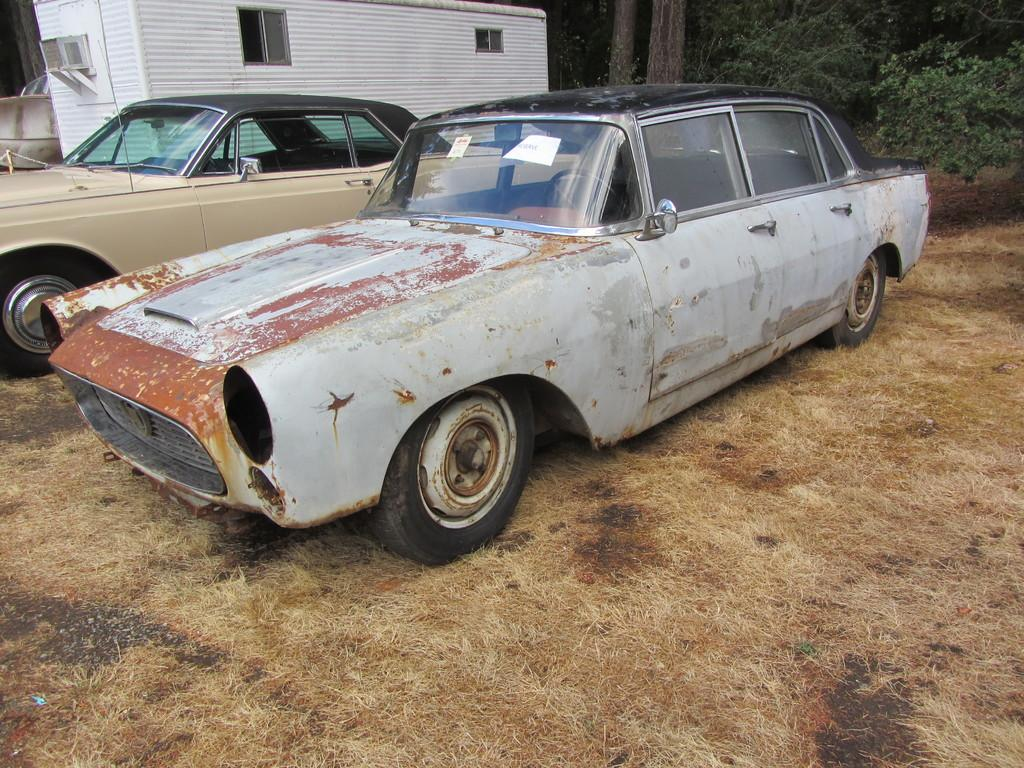How many cars are present in the image? There are two cars in the image. What is the surface on which the cars are located? The cars are on dry grass. What can be seen in the background of the image? There is a house and plants in the background of the image. What type of teaching is being conducted in the image? There is no teaching or educational activity depicted in the image; it features two cars on dry grass with a house and plants in the background. 